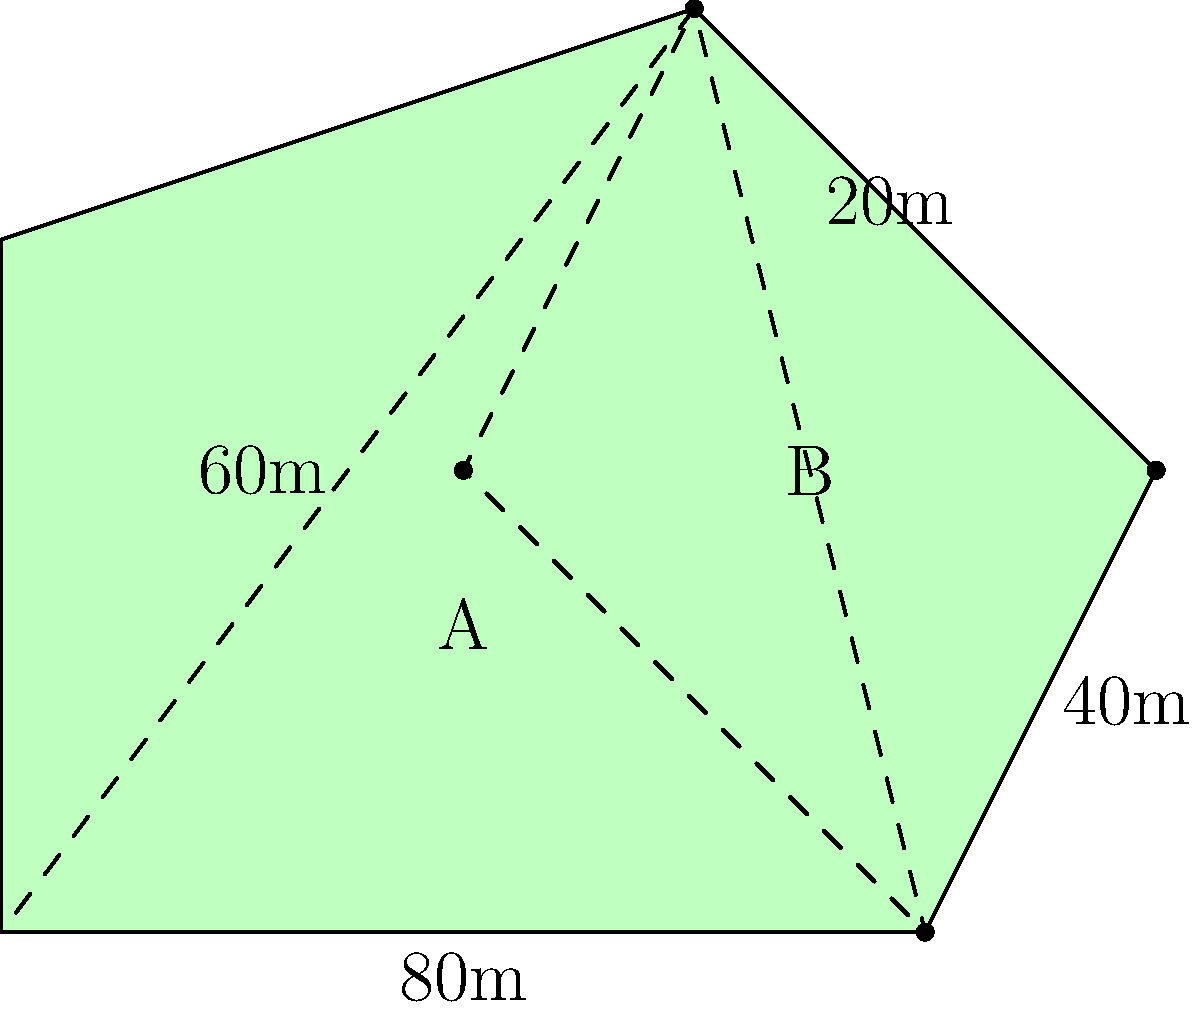You've inherited an irregular-shaped field from your neighbor, and you want to calculate its area to determine how many sheep it can support. The field can be divided into two geometric shapes: a triangle and a rectangle, as shown in the diagram. If the base of the triangle is 80m and its height is 60m, and the rectangle has a width of 20m and a length of 40m, what is the total area of the field in square meters? Let's approach this step-by-step:

1. Calculate the area of the triangle:
   Area of a triangle = $\frac{1}{2} \times$ base $\times$ height
   $A_{\text{triangle}} = \frac{1}{2} \times 80\text{m} \times 60\text{m} = 2400\text{m}^2$

2. Calculate the area of the rectangle:
   Area of a rectangle = length $\times$ width
   $A_{\text{rectangle}} = 40\text{m} \times 20\text{m} = 800\text{m}^2$

3. Sum up the areas to get the total area of the field:
   $A_{\text{total}} = A_{\text{triangle}} + A_{\text{rectangle}}$
   $A_{\text{total}} = 2400\text{m}^2 + 800\text{m}^2 = 3200\text{m}^2$

Therefore, the total area of the irregular-shaped field is 3200 square meters.
Answer: 3200 m² 